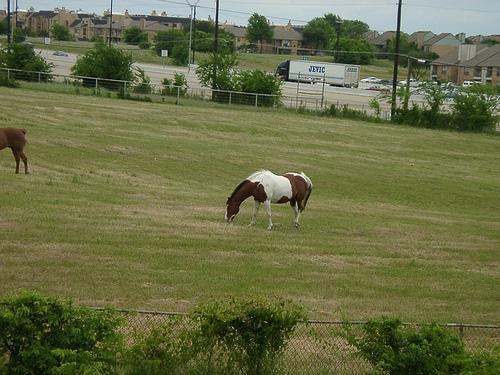How many horses are shown?
Give a very brief answer. 2. 